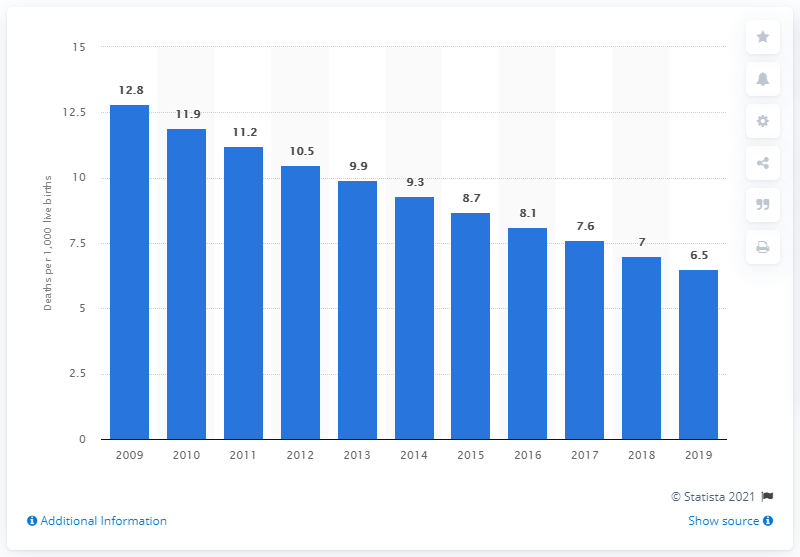List a handful of essential elements in this visual. In 2019, the infant mortality rate in the Maldives was 6.5 deaths per 1,000 live births. 